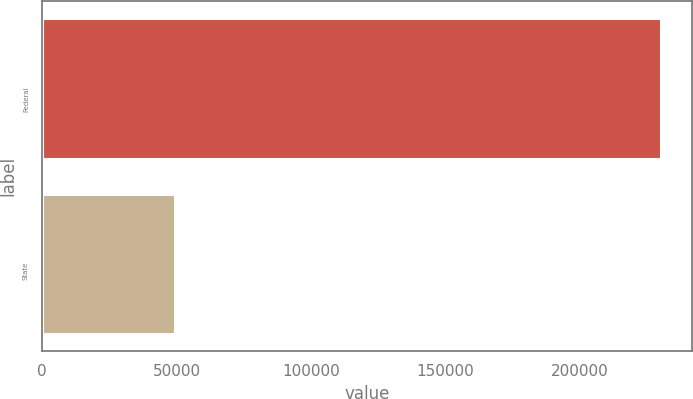<chart> <loc_0><loc_0><loc_500><loc_500><bar_chart><fcel>Federal<fcel>State<nl><fcel>230477<fcel>49333<nl></chart> 